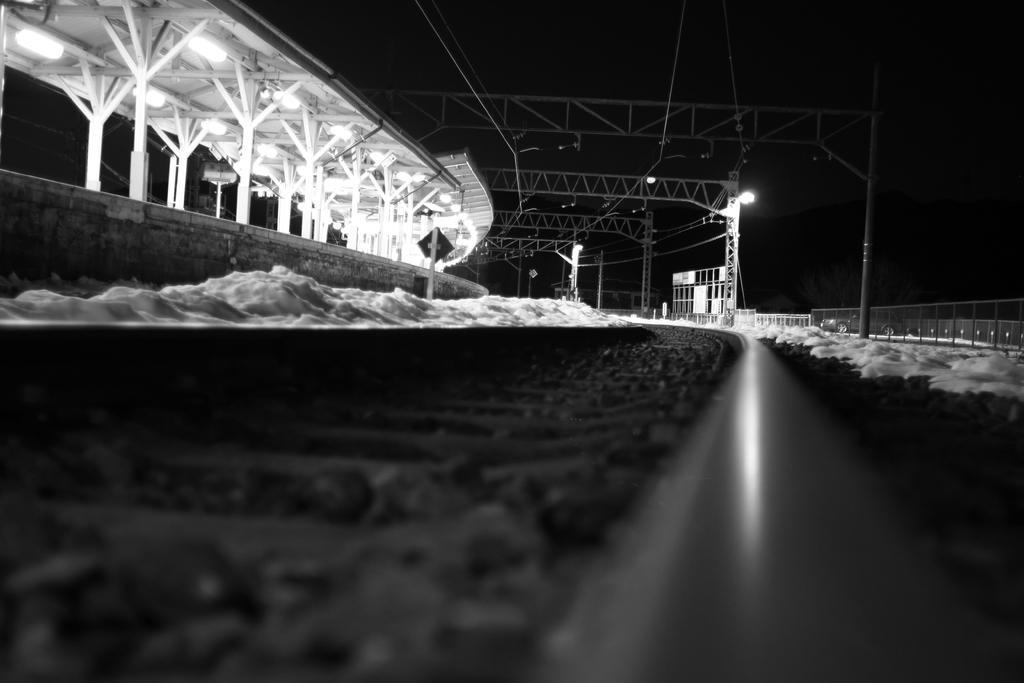How would you summarize this image in a sentence or two? In this image I can see the track. To the left there is a platform and to the right I can see the poles and lights. I can also see the railing to the right. And I can see the black background. 